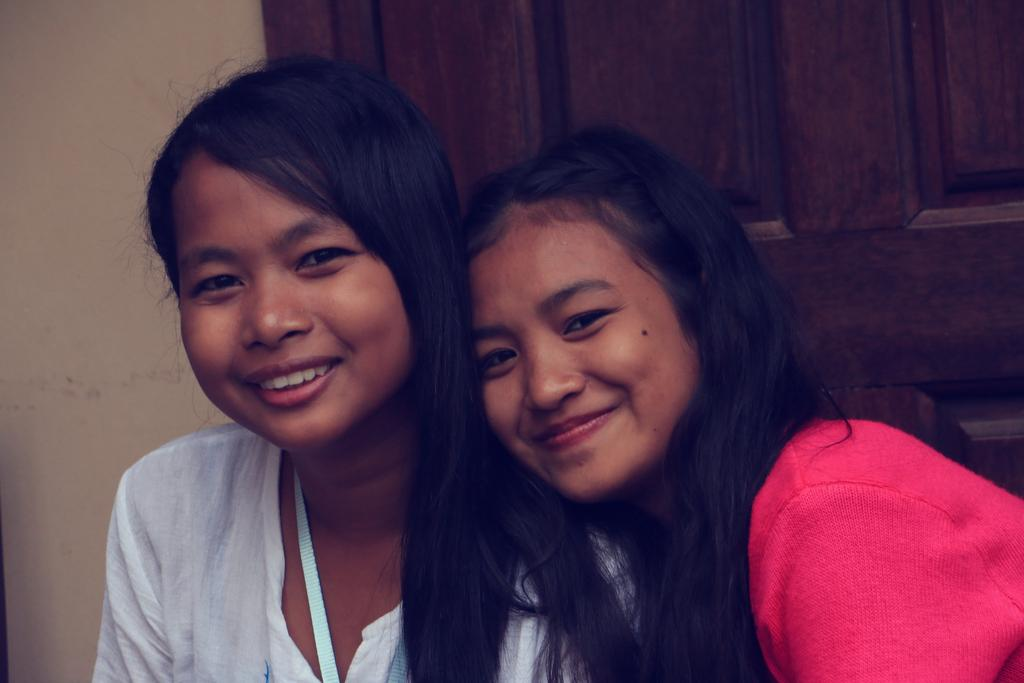How many people are in the image? There are persons in the image, but the exact number is not specified. What is the facial expression of the persons in the image? The persons in the image are smiling. What can be seen in the background of the image? There is a door visible in the background of the image. What type of stem can be seen growing from the person's head in the image? There is no stem growing from anyone's head in the image. 